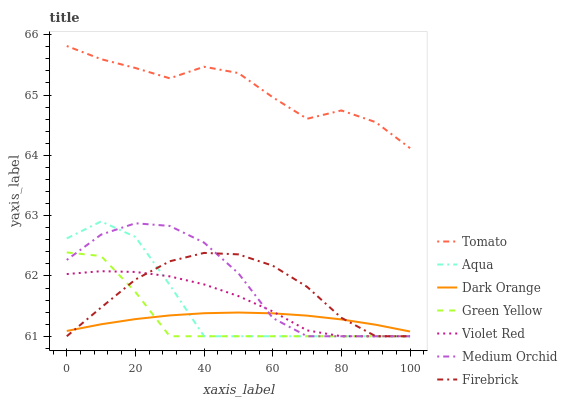Does Dark Orange have the minimum area under the curve?
Answer yes or no. No. Does Dark Orange have the maximum area under the curve?
Answer yes or no. No. Is Violet Red the smoothest?
Answer yes or no. No. Is Violet Red the roughest?
Answer yes or no. No. Does Dark Orange have the lowest value?
Answer yes or no. No. Does Violet Red have the highest value?
Answer yes or no. No. Is Aqua less than Tomato?
Answer yes or no. Yes. Is Tomato greater than Aqua?
Answer yes or no. Yes. Does Aqua intersect Tomato?
Answer yes or no. No. 